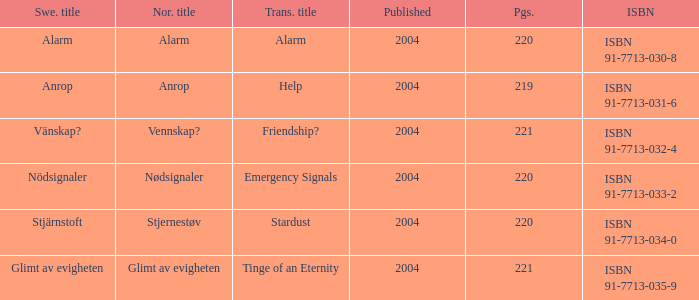How many pages associated with isbn 91-7713-035-9? 221.0. I'm looking to parse the entire table for insights. Could you assist me with that? {'header': ['Swe. title', 'Nor. title', 'Trans. title', 'Published', 'Pgs.', 'ISBN'], 'rows': [['Alarm', 'Alarm', 'Alarm', '2004', '220', 'ISBN 91-7713-030-8'], ['Anrop', 'Anrop', 'Help', '2004', '219', 'ISBN 91-7713-031-6'], ['Vänskap?', 'Vennskap?', 'Friendship?', '2004', '221', 'ISBN 91-7713-032-4'], ['Nödsignaler', 'Nødsignaler', 'Emergency Signals', '2004', '220', 'ISBN 91-7713-033-2'], ['Stjärnstoft', 'Stjernestøv', 'Stardust', '2004', '220', 'ISBN 91-7713-034-0'], ['Glimt av evigheten', 'Glimt av evigheten', 'Tinge of an Eternity', '2004', '221', 'ISBN 91-7713-035-9']]} 